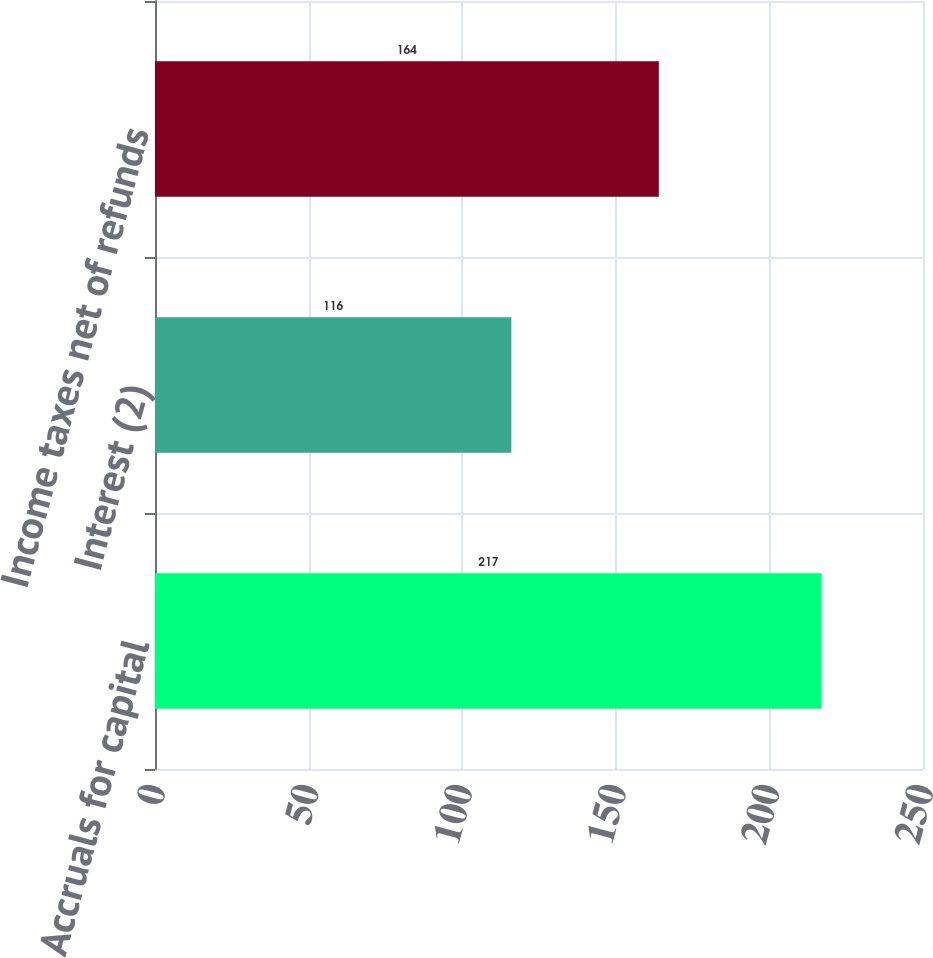Convert chart to OTSL. <chart><loc_0><loc_0><loc_500><loc_500><bar_chart><fcel>Accruals for capital<fcel>Interest (2)<fcel>Income taxes net of refunds<nl><fcel>217<fcel>116<fcel>164<nl></chart> 